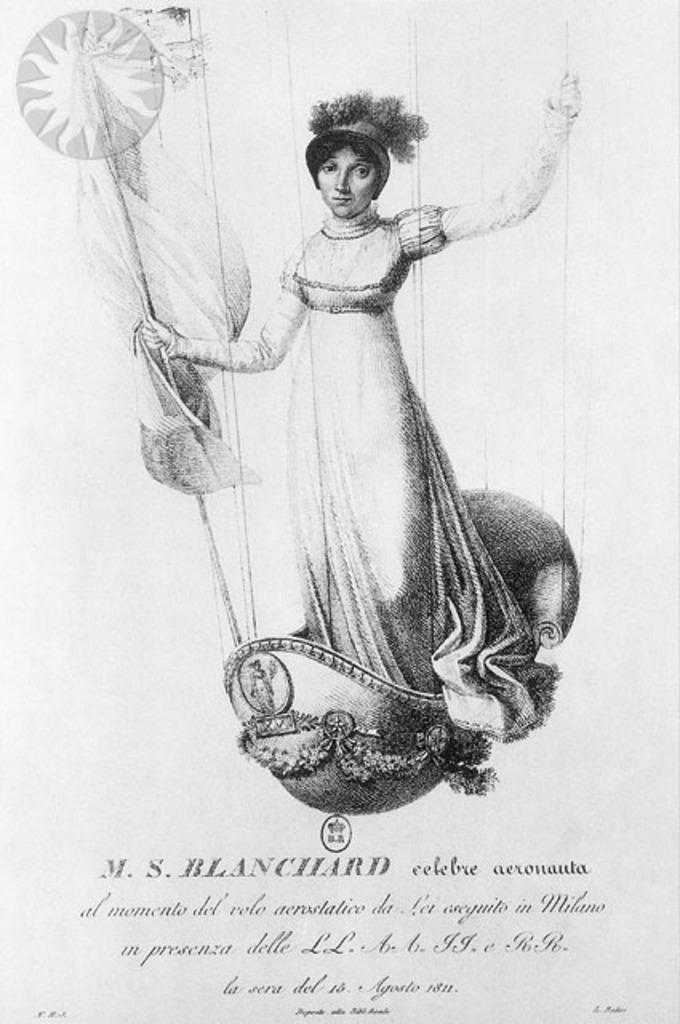What is the color scheme of the image? The image is in black and white. What can be seen in the image besides the woman? There is a poster in the image. What is the woman doing in the image? The woman is standing and holding a stick in her hand. What is written on the poster? There is text written at the bottom of the poster. What type of cough can be heard from the woman in the image? There is no sound in the image, so it is not possible to determine if the woman is coughing or not. 